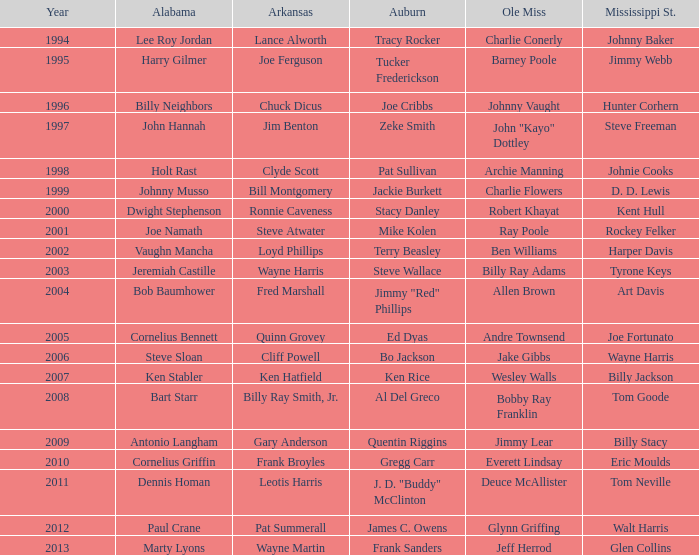Who was the participant affiliated with ole miss in years subsequent to 2008 with a mississippi st. nickname of eric moulds? Everett Lindsay. 